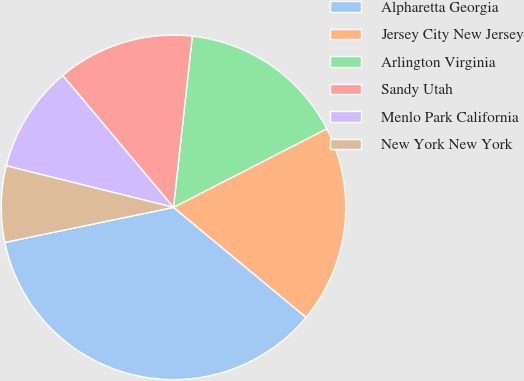Convert chart to OTSL. <chart><loc_0><loc_0><loc_500><loc_500><pie_chart><fcel>Alpharetta Georgia<fcel>Jersey City New Jersey<fcel>Arlington Virginia<fcel>Sandy Utah<fcel>Menlo Park California<fcel>New York New York<nl><fcel>35.71%<fcel>18.57%<fcel>15.71%<fcel>12.86%<fcel>10.0%<fcel>7.14%<nl></chart> 